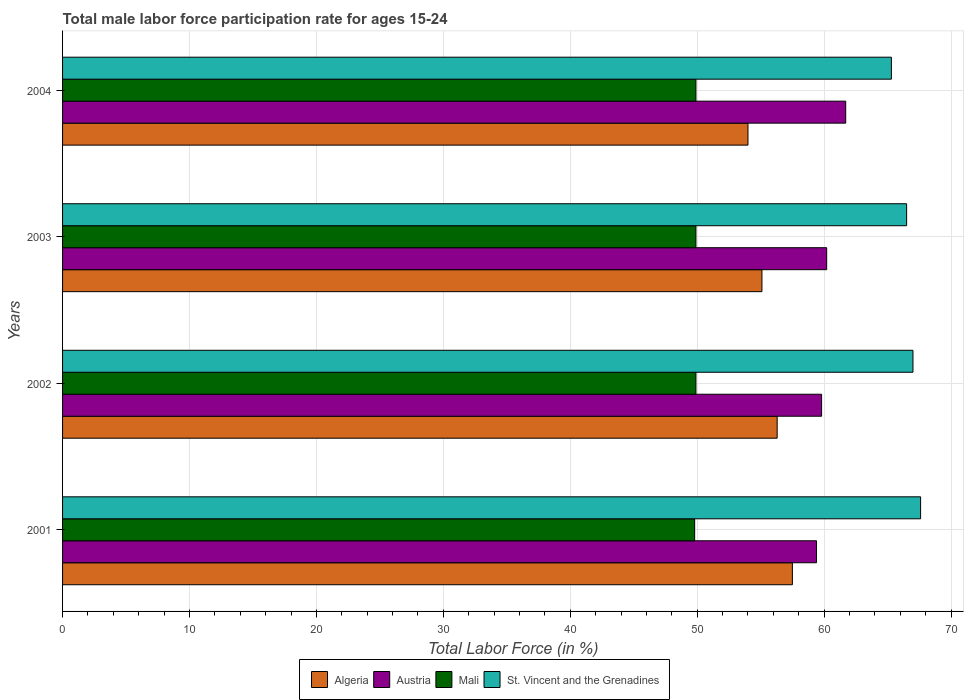How many groups of bars are there?
Give a very brief answer. 4. Are the number of bars per tick equal to the number of legend labels?
Your response must be concise. Yes. Are the number of bars on each tick of the Y-axis equal?
Your answer should be very brief. Yes. What is the label of the 2nd group of bars from the top?
Ensure brevity in your answer.  2003. In how many cases, is the number of bars for a given year not equal to the number of legend labels?
Your answer should be very brief. 0. What is the male labor force participation rate in Algeria in 2001?
Offer a terse response. 57.5. Across all years, what is the maximum male labor force participation rate in St. Vincent and the Grenadines?
Offer a terse response. 67.6. Across all years, what is the minimum male labor force participation rate in Austria?
Make the answer very short. 59.4. In which year was the male labor force participation rate in Algeria maximum?
Your answer should be compact. 2001. In which year was the male labor force participation rate in Mali minimum?
Your answer should be compact. 2001. What is the total male labor force participation rate in Mali in the graph?
Make the answer very short. 199.5. What is the difference between the male labor force participation rate in St. Vincent and the Grenadines in 2004 and the male labor force participation rate in Austria in 2003?
Provide a short and direct response. 5.1. What is the average male labor force participation rate in Mali per year?
Offer a terse response. 49.88. In the year 2004, what is the difference between the male labor force participation rate in St. Vincent and the Grenadines and male labor force participation rate in Mali?
Keep it short and to the point. 15.4. In how many years, is the male labor force participation rate in Mali greater than 20 %?
Ensure brevity in your answer.  4. What is the ratio of the male labor force participation rate in Mali in 2003 to that in 2004?
Provide a short and direct response. 1. Is the difference between the male labor force participation rate in St. Vincent and the Grenadines in 2001 and 2002 greater than the difference between the male labor force participation rate in Mali in 2001 and 2002?
Your response must be concise. Yes. What is the difference between the highest and the lowest male labor force participation rate in Mali?
Ensure brevity in your answer.  0.1. Is it the case that in every year, the sum of the male labor force participation rate in Algeria and male labor force participation rate in St. Vincent and the Grenadines is greater than the sum of male labor force participation rate in Austria and male labor force participation rate in Mali?
Your answer should be compact. Yes. What does the 1st bar from the top in 2002 represents?
Your response must be concise. St. Vincent and the Grenadines. What does the 2nd bar from the bottom in 2004 represents?
Your answer should be very brief. Austria. Is it the case that in every year, the sum of the male labor force participation rate in St. Vincent and the Grenadines and male labor force participation rate in Austria is greater than the male labor force participation rate in Algeria?
Give a very brief answer. Yes. How many years are there in the graph?
Provide a short and direct response. 4. How many legend labels are there?
Give a very brief answer. 4. How are the legend labels stacked?
Provide a succinct answer. Horizontal. What is the title of the graph?
Keep it short and to the point. Total male labor force participation rate for ages 15-24. What is the Total Labor Force (in %) in Algeria in 2001?
Your answer should be compact. 57.5. What is the Total Labor Force (in %) in Austria in 2001?
Your answer should be very brief. 59.4. What is the Total Labor Force (in %) in Mali in 2001?
Keep it short and to the point. 49.8. What is the Total Labor Force (in %) in St. Vincent and the Grenadines in 2001?
Provide a short and direct response. 67.6. What is the Total Labor Force (in %) in Algeria in 2002?
Your answer should be compact. 56.3. What is the Total Labor Force (in %) in Austria in 2002?
Offer a terse response. 59.8. What is the Total Labor Force (in %) of Mali in 2002?
Keep it short and to the point. 49.9. What is the Total Labor Force (in %) in Algeria in 2003?
Offer a very short reply. 55.1. What is the Total Labor Force (in %) of Austria in 2003?
Your answer should be compact. 60.2. What is the Total Labor Force (in %) of Mali in 2003?
Offer a terse response. 49.9. What is the Total Labor Force (in %) in St. Vincent and the Grenadines in 2003?
Give a very brief answer. 66.5. What is the Total Labor Force (in %) in Algeria in 2004?
Provide a short and direct response. 54. What is the Total Labor Force (in %) in Austria in 2004?
Provide a short and direct response. 61.7. What is the Total Labor Force (in %) of Mali in 2004?
Provide a short and direct response. 49.9. What is the Total Labor Force (in %) of St. Vincent and the Grenadines in 2004?
Provide a succinct answer. 65.3. Across all years, what is the maximum Total Labor Force (in %) of Algeria?
Give a very brief answer. 57.5. Across all years, what is the maximum Total Labor Force (in %) of Austria?
Your answer should be compact. 61.7. Across all years, what is the maximum Total Labor Force (in %) of Mali?
Ensure brevity in your answer.  49.9. Across all years, what is the maximum Total Labor Force (in %) in St. Vincent and the Grenadines?
Give a very brief answer. 67.6. Across all years, what is the minimum Total Labor Force (in %) in Algeria?
Your response must be concise. 54. Across all years, what is the minimum Total Labor Force (in %) of Austria?
Make the answer very short. 59.4. Across all years, what is the minimum Total Labor Force (in %) of Mali?
Provide a short and direct response. 49.8. Across all years, what is the minimum Total Labor Force (in %) in St. Vincent and the Grenadines?
Your response must be concise. 65.3. What is the total Total Labor Force (in %) in Algeria in the graph?
Give a very brief answer. 222.9. What is the total Total Labor Force (in %) in Austria in the graph?
Offer a terse response. 241.1. What is the total Total Labor Force (in %) in Mali in the graph?
Keep it short and to the point. 199.5. What is the total Total Labor Force (in %) of St. Vincent and the Grenadines in the graph?
Your answer should be compact. 266.4. What is the difference between the Total Labor Force (in %) of Austria in 2001 and that in 2002?
Keep it short and to the point. -0.4. What is the difference between the Total Labor Force (in %) in Mali in 2001 and that in 2002?
Your answer should be compact. -0.1. What is the difference between the Total Labor Force (in %) of Algeria in 2001 and that in 2003?
Ensure brevity in your answer.  2.4. What is the difference between the Total Labor Force (in %) in Mali in 2001 and that in 2003?
Offer a terse response. -0.1. What is the difference between the Total Labor Force (in %) of Algeria in 2001 and that in 2004?
Offer a very short reply. 3.5. What is the difference between the Total Labor Force (in %) of Mali in 2001 and that in 2004?
Offer a very short reply. -0.1. What is the difference between the Total Labor Force (in %) of St. Vincent and the Grenadines in 2001 and that in 2004?
Ensure brevity in your answer.  2.3. What is the difference between the Total Labor Force (in %) in St. Vincent and the Grenadines in 2002 and that in 2003?
Make the answer very short. 0.5. What is the difference between the Total Labor Force (in %) in Algeria in 2002 and that in 2004?
Give a very brief answer. 2.3. What is the difference between the Total Labor Force (in %) in St. Vincent and the Grenadines in 2002 and that in 2004?
Provide a short and direct response. 1.7. What is the difference between the Total Labor Force (in %) in St. Vincent and the Grenadines in 2003 and that in 2004?
Give a very brief answer. 1.2. What is the difference between the Total Labor Force (in %) in Algeria in 2001 and the Total Labor Force (in %) in Mali in 2002?
Give a very brief answer. 7.6. What is the difference between the Total Labor Force (in %) in Algeria in 2001 and the Total Labor Force (in %) in St. Vincent and the Grenadines in 2002?
Provide a succinct answer. -9.5. What is the difference between the Total Labor Force (in %) of Austria in 2001 and the Total Labor Force (in %) of Mali in 2002?
Ensure brevity in your answer.  9.5. What is the difference between the Total Labor Force (in %) of Mali in 2001 and the Total Labor Force (in %) of St. Vincent and the Grenadines in 2002?
Offer a very short reply. -17.2. What is the difference between the Total Labor Force (in %) of Algeria in 2001 and the Total Labor Force (in %) of Mali in 2003?
Ensure brevity in your answer.  7.6. What is the difference between the Total Labor Force (in %) in Algeria in 2001 and the Total Labor Force (in %) in St. Vincent and the Grenadines in 2003?
Keep it short and to the point. -9. What is the difference between the Total Labor Force (in %) in Austria in 2001 and the Total Labor Force (in %) in St. Vincent and the Grenadines in 2003?
Your answer should be very brief. -7.1. What is the difference between the Total Labor Force (in %) in Mali in 2001 and the Total Labor Force (in %) in St. Vincent and the Grenadines in 2003?
Give a very brief answer. -16.7. What is the difference between the Total Labor Force (in %) of Algeria in 2001 and the Total Labor Force (in %) of Mali in 2004?
Provide a succinct answer. 7.6. What is the difference between the Total Labor Force (in %) of Algeria in 2001 and the Total Labor Force (in %) of St. Vincent and the Grenadines in 2004?
Your answer should be very brief. -7.8. What is the difference between the Total Labor Force (in %) in Austria in 2001 and the Total Labor Force (in %) in Mali in 2004?
Provide a succinct answer. 9.5. What is the difference between the Total Labor Force (in %) in Austria in 2001 and the Total Labor Force (in %) in St. Vincent and the Grenadines in 2004?
Keep it short and to the point. -5.9. What is the difference between the Total Labor Force (in %) of Mali in 2001 and the Total Labor Force (in %) of St. Vincent and the Grenadines in 2004?
Your response must be concise. -15.5. What is the difference between the Total Labor Force (in %) in Algeria in 2002 and the Total Labor Force (in %) in Austria in 2003?
Ensure brevity in your answer.  -3.9. What is the difference between the Total Labor Force (in %) of Algeria in 2002 and the Total Labor Force (in %) of Mali in 2003?
Make the answer very short. 6.4. What is the difference between the Total Labor Force (in %) of Algeria in 2002 and the Total Labor Force (in %) of St. Vincent and the Grenadines in 2003?
Make the answer very short. -10.2. What is the difference between the Total Labor Force (in %) in Austria in 2002 and the Total Labor Force (in %) in Mali in 2003?
Your response must be concise. 9.9. What is the difference between the Total Labor Force (in %) in Mali in 2002 and the Total Labor Force (in %) in St. Vincent and the Grenadines in 2003?
Your answer should be very brief. -16.6. What is the difference between the Total Labor Force (in %) of Algeria in 2002 and the Total Labor Force (in %) of Austria in 2004?
Your answer should be compact. -5.4. What is the difference between the Total Labor Force (in %) in Algeria in 2002 and the Total Labor Force (in %) in Mali in 2004?
Your response must be concise. 6.4. What is the difference between the Total Labor Force (in %) of Algeria in 2002 and the Total Labor Force (in %) of St. Vincent and the Grenadines in 2004?
Give a very brief answer. -9. What is the difference between the Total Labor Force (in %) of Austria in 2002 and the Total Labor Force (in %) of Mali in 2004?
Your answer should be very brief. 9.9. What is the difference between the Total Labor Force (in %) of Austria in 2002 and the Total Labor Force (in %) of St. Vincent and the Grenadines in 2004?
Ensure brevity in your answer.  -5.5. What is the difference between the Total Labor Force (in %) of Mali in 2002 and the Total Labor Force (in %) of St. Vincent and the Grenadines in 2004?
Your answer should be compact. -15.4. What is the difference between the Total Labor Force (in %) of Austria in 2003 and the Total Labor Force (in %) of Mali in 2004?
Your answer should be compact. 10.3. What is the difference between the Total Labor Force (in %) of Mali in 2003 and the Total Labor Force (in %) of St. Vincent and the Grenadines in 2004?
Ensure brevity in your answer.  -15.4. What is the average Total Labor Force (in %) of Algeria per year?
Offer a very short reply. 55.73. What is the average Total Labor Force (in %) in Austria per year?
Your answer should be compact. 60.27. What is the average Total Labor Force (in %) of Mali per year?
Offer a terse response. 49.88. What is the average Total Labor Force (in %) of St. Vincent and the Grenadines per year?
Provide a short and direct response. 66.6. In the year 2001, what is the difference between the Total Labor Force (in %) in Algeria and Total Labor Force (in %) in Austria?
Your response must be concise. -1.9. In the year 2001, what is the difference between the Total Labor Force (in %) in Algeria and Total Labor Force (in %) in Mali?
Your response must be concise. 7.7. In the year 2001, what is the difference between the Total Labor Force (in %) in Algeria and Total Labor Force (in %) in St. Vincent and the Grenadines?
Keep it short and to the point. -10.1. In the year 2001, what is the difference between the Total Labor Force (in %) in Austria and Total Labor Force (in %) in St. Vincent and the Grenadines?
Your answer should be compact. -8.2. In the year 2001, what is the difference between the Total Labor Force (in %) of Mali and Total Labor Force (in %) of St. Vincent and the Grenadines?
Offer a terse response. -17.8. In the year 2002, what is the difference between the Total Labor Force (in %) in Algeria and Total Labor Force (in %) in Austria?
Make the answer very short. -3.5. In the year 2002, what is the difference between the Total Labor Force (in %) of Algeria and Total Labor Force (in %) of Mali?
Provide a succinct answer. 6.4. In the year 2002, what is the difference between the Total Labor Force (in %) of Algeria and Total Labor Force (in %) of St. Vincent and the Grenadines?
Keep it short and to the point. -10.7. In the year 2002, what is the difference between the Total Labor Force (in %) of Austria and Total Labor Force (in %) of Mali?
Your answer should be compact. 9.9. In the year 2002, what is the difference between the Total Labor Force (in %) in Austria and Total Labor Force (in %) in St. Vincent and the Grenadines?
Provide a short and direct response. -7.2. In the year 2002, what is the difference between the Total Labor Force (in %) of Mali and Total Labor Force (in %) of St. Vincent and the Grenadines?
Your answer should be very brief. -17.1. In the year 2003, what is the difference between the Total Labor Force (in %) in Algeria and Total Labor Force (in %) in Austria?
Ensure brevity in your answer.  -5.1. In the year 2003, what is the difference between the Total Labor Force (in %) of Algeria and Total Labor Force (in %) of Mali?
Offer a very short reply. 5.2. In the year 2003, what is the difference between the Total Labor Force (in %) in Algeria and Total Labor Force (in %) in St. Vincent and the Grenadines?
Make the answer very short. -11.4. In the year 2003, what is the difference between the Total Labor Force (in %) of Mali and Total Labor Force (in %) of St. Vincent and the Grenadines?
Offer a terse response. -16.6. In the year 2004, what is the difference between the Total Labor Force (in %) in Algeria and Total Labor Force (in %) in Austria?
Keep it short and to the point. -7.7. In the year 2004, what is the difference between the Total Labor Force (in %) in Algeria and Total Labor Force (in %) in Mali?
Your response must be concise. 4.1. In the year 2004, what is the difference between the Total Labor Force (in %) of Algeria and Total Labor Force (in %) of St. Vincent and the Grenadines?
Offer a terse response. -11.3. In the year 2004, what is the difference between the Total Labor Force (in %) of Mali and Total Labor Force (in %) of St. Vincent and the Grenadines?
Keep it short and to the point. -15.4. What is the ratio of the Total Labor Force (in %) in Algeria in 2001 to that in 2002?
Your answer should be compact. 1.02. What is the ratio of the Total Labor Force (in %) in Austria in 2001 to that in 2002?
Provide a short and direct response. 0.99. What is the ratio of the Total Labor Force (in %) of Mali in 2001 to that in 2002?
Your answer should be compact. 1. What is the ratio of the Total Labor Force (in %) of St. Vincent and the Grenadines in 2001 to that in 2002?
Ensure brevity in your answer.  1.01. What is the ratio of the Total Labor Force (in %) of Algeria in 2001 to that in 2003?
Your answer should be very brief. 1.04. What is the ratio of the Total Labor Force (in %) in Austria in 2001 to that in 2003?
Provide a succinct answer. 0.99. What is the ratio of the Total Labor Force (in %) of St. Vincent and the Grenadines in 2001 to that in 2003?
Your response must be concise. 1.02. What is the ratio of the Total Labor Force (in %) in Algeria in 2001 to that in 2004?
Provide a succinct answer. 1.06. What is the ratio of the Total Labor Force (in %) of Austria in 2001 to that in 2004?
Give a very brief answer. 0.96. What is the ratio of the Total Labor Force (in %) in Mali in 2001 to that in 2004?
Your answer should be compact. 1. What is the ratio of the Total Labor Force (in %) of St. Vincent and the Grenadines in 2001 to that in 2004?
Your answer should be compact. 1.04. What is the ratio of the Total Labor Force (in %) of Algeria in 2002 to that in 2003?
Your answer should be very brief. 1.02. What is the ratio of the Total Labor Force (in %) in Mali in 2002 to that in 2003?
Offer a terse response. 1. What is the ratio of the Total Labor Force (in %) in St. Vincent and the Grenadines in 2002 to that in 2003?
Ensure brevity in your answer.  1.01. What is the ratio of the Total Labor Force (in %) of Algeria in 2002 to that in 2004?
Provide a short and direct response. 1.04. What is the ratio of the Total Labor Force (in %) in Austria in 2002 to that in 2004?
Make the answer very short. 0.97. What is the ratio of the Total Labor Force (in %) in St. Vincent and the Grenadines in 2002 to that in 2004?
Make the answer very short. 1.03. What is the ratio of the Total Labor Force (in %) of Algeria in 2003 to that in 2004?
Provide a short and direct response. 1.02. What is the ratio of the Total Labor Force (in %) in Austria in 2003 to that in 2004?
Keep it short and to the point. 0.98. What is the ratio of the Total Labor Force (in %) in St. Vincent and the Grenadines in 2003 to that in 2004?
Make the answer very short. 1.02. What is the difference between the highest and the second highest Total Labor Force (in %) in Algeria?
Ensure brevity in your answer.  1.2. What is the difference between the highest and the second highest Total Labor Force (in %) of Austria?
Keep it short and to the point. 1.5. What is the difference between the highest and the second highest Total Labor Force (in %) in Mali?
Ensure brevity in your answer.  0. What is the difference between the highest and the second highest Total Labor Force (in %) in St. Vincent and the Grenadines?
Offer a terse response. 0.6. 